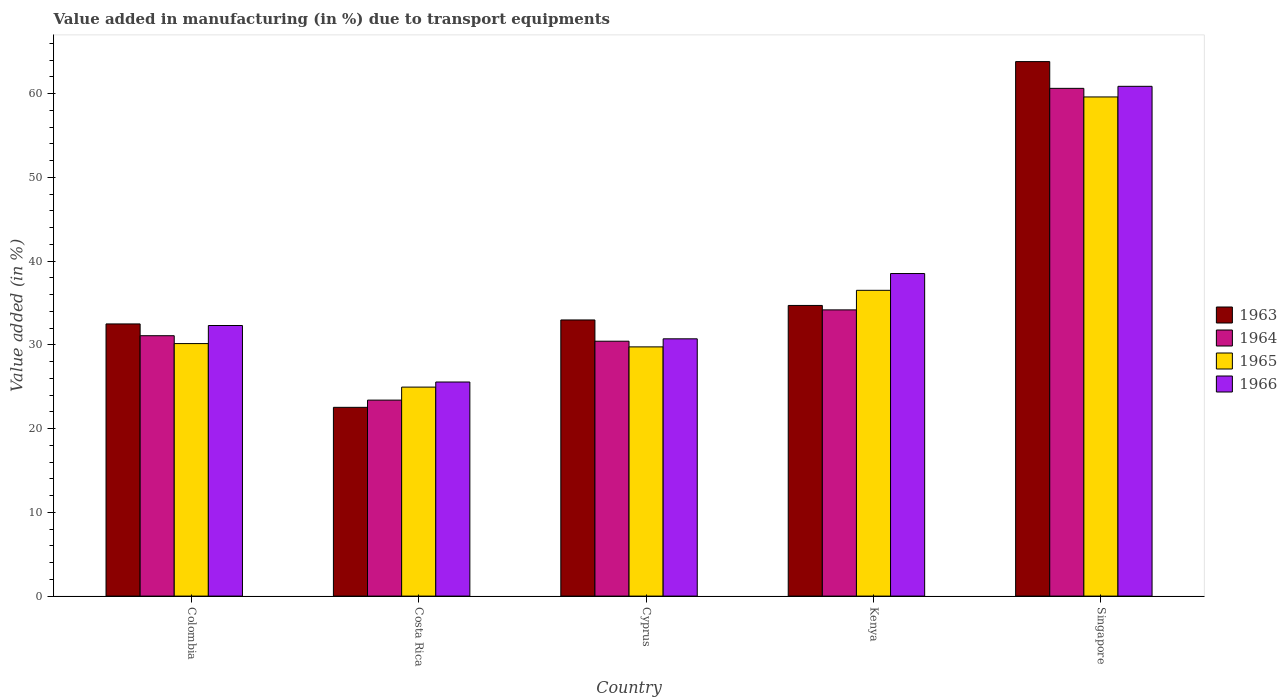How many different coloured bars are there?
Keep it short and to the point. 4. Are the number of bars on each tick of the X-axis equal?
Your answer should be compact. Yes. How many bars are there on the 4th tick from the left?
Provide a short and direct response. 4. How many bars are there on the 2nd tick from the right?
Keep it short and to the point. 4. What is the label of the 2nd group of bars from the left?
Make the answer very short. Costa Rica. What is the percentage of value added in manufacturing due to transport equipments in 1966 in Singapore?
Provide a short and direct response. 60.86. Across all countries, what is the maximum percentage of value added in manufacturing due to transport equipments in 1965?
Provide a succinct answer. 59.59. Across all countries, what is the minimum percentage of value added in manufacturing due to transport equipments in 1964?
Your answer should be very brief. 23.4. In which country was the percentage of value added in manufacturing due to transport equipments in 1965 maximum?
Ensure brevity in your answer.  Singapore. What is the total percentage of value added in manufacturing due to transport equipments in 1965 in the graph?
Provide a succinct answer. 180.94. What is the difference between the percentage of value added in manufacturing due to transport equipments in 1964 in Costa Rica and that in Singapore?
Make the answer very short. -37.22. What is the difference between the percentage of value added in manufacturing due to transport equipments in 1964 in Singapore and the percentage of value added in manufacturing due to transport equipments in 1966 in Kenya?
Ensure brevity in your answer.  22.11. What is the average percentage of value added in manufacturing due to transport equipments in 1965 per country?
Provide a succinct answer. 36.19. What is the difference between the percentage of value added in manufacturing due to transport equipments of/in 1963 and percentage of value added in manufacturing due to transport equipments of/in 1966 in Kenya?
Provide a short and direct response. -3.81. In how many countries, is the percentage of value added in manufacturing due to transport equipments in 1963 greater than 20 %?
Your answer should be compact. 5. What is the ratio of the percentage of value added in manufacturing due to transport equipments in 1966 in Colombia to that in Costa Rica?
Ensure brevity in your answer.  1.26. Is the difference between the percentage of value added in manufacturing due to transport equipments in 1963 in Colombia and Kenya greater than the difference between the percentage of value added in manufacturing due to transport equipments in 1966 in Colombia and Kenya?
Offer a very short reply. Yes. What is the difference between the highest and the second highest percentage of value added in manufacturing due to transport equipments in 1965?
Your response must be concise. 23.09. What is the difference between the highest and the lowest percentage of value added in manufacturing due to transport equipments in 1963?
Make the answer very short. 41.28. In how many countries, is the percentage of value added in manufacturing due to transport equipments in 1966 greater than the average percentage of value added in manufacturing due to transport equipments in 1966 taken over all countries?
Keep it short and to the point. 2. Is the sum of the percentage of value added in manufacturing due to transport equipments in 1966 in Costa Rica and Cyprus greater than the maximum percentage of value added in manufacturing due to transport equipments in 1964 across all countries?
Provide a succinct answer. No. What does the 2nd bar from the left in Colombia represents?
Provide a succinct answer. 1964. Are all the bars in the graph horizontal?
Your response must be concise. No. Are the values on the major ticks of Y-axis written in scientific E-notation?
Provide a succinct answer. No. What is the title of the graph?
Make the answer very short. Value added in manufacturing (in %) due to transport equipments. Does "1991" appear as one of the legend labels in the graph?
Give a very brief answer. No. What is the label or title of the Y-axis?
Provide a short and direct response. Value added (in %). What is the Value added (in %) of 1963 in Colombia?
Make the answer very short. 32.49. What is the Value added (in %) in 1964 in Colombia?
Offer a very short reply. 31.09. What is the Value added (in %) in 1965 in Colombia?
Your answer should be very brief. 30.15. What is the Value added (in %) in 1966 in Colombia?
Keep it short and to the point. 32.3. What is the Value added (in %) of 1963 in Costa Rica?
Your answer should be compact. 22.53. What is the Value added (in %) of 1964 in Costa Rica?
Give a very brief answer. 23.4. What is the Value added (in %) of 1965 in Costa Rica?
Ensure brevity in your answer.  24.95. What is the Value added (in %) of 1966 in Costa Rica?
Keep it short and to the point. 25.56. What is the Value added (in %) in 1963 in Cyprus?
Your answer should be compact. 32.97. What is the Value added (in %) of 1964 in Cyprus?
Offer a terse response. 30.43. What is the Value added (in %) in 1965 in Cyprus?
Your response must be concise. 29.75. What is the Value added (in %) in 1966 in Cyprus?
Provide a succinct answer. 30.72. What is the Value added (in %) in 1963 in Kenya?
Your answer should be very brief. 34.7. What is the Value added (in %) of 1964 in Kenya?
Your response must be concise. 34.17. What is the Value added (in %) of 1965 in Kenya?
Keep it short and to the point. 36.5. What is the Value added (in %) in 1966 in Kenya?
Make the answer very short. 38.51. What is the Value added (in %) of 1963 in Singapore?
Offer a very short reply. 63.81. What is the Value added (in %) of 1964 in Singapore?
Make the answer very short. 60.62. What is the Value added (in %) of 1965 in Singapore?
Ensure brevity in your answer.  59.59. What is the Value added (in %) of 1966 in Singapore?
Your answer should be compact. 60.86. Across all countries, what is the maximum Value added (in %) of 1963?
Give a very brief answer. 63.81. Across all countries, what is the maximum Value added (in %) in 1964?
Your answer should be compact. 60.62. Across all countries, what is the maximum Value added (in %) of 1965?
Ensure brevity in your answer.  59.59. Across all countries, what is the maximum Value added (in %) in 1966?
Your answer should be compact. 60.86. Across all countries, what is the minimum Value added (in %) in 1963?
Give a very brief answer. 22.53. Across all countries, what is the minimum Value added (in %) of 1964?
Provide a succinct answer. 23.4. Across all countries, what is the minimum Value added (in %) in 1965?
Keep it short and to the point. 24.95. Across all countries, what is the minimum Value added (in %) of 1966?
Offer a terse response. 25.56. What is the total Value added (in %) of 1963 in the graph?
Provide a short and direct response. 186.5. What is the total Value added (in %) of 1964 in the graph?
Provide a short and direct response. 179.7. What is the total Value added (in %) of 1965 in the graph?
Ensure brevity in your answer.  180.94. What is the total Value added (in %) of 1966 in the graph?
Your answer should be compact. 187.95. What is the difference between the Value added (in %) of 1963 in Colombia and that in Costa Rica?
Provide a succinct answer. 9.96. What is the difference between the Value added (in %) in 1964 in Colombia and that in Costa Rica?
Your answer should be very brief. 7.69. What is the difference between the Value added (in %) of 1965 in Colombia and that in Costa Rica?
Your answer should be compact. 5.2. What is the difference between the Value added (in %) in 1966 in Colombia and that in Costa Rica?
Provide a short and direct response. 6.74. What is the difference between the Value added (in %) in 1963 in Colombia and that in Cyprus?
Offer a very short reply. -0.47. What is the difference between the Value added (in %) of 1964 in Colombia and that in Cyprus?
Ensure brevity in your answer.  0.66. What is the difference between the Value added (in %) of 1965 in Colombia and that in Cyprus?
Your response must be concise. 0.39. What is the difference between the Value added (in %) in 1966 in Colombia and that in Cyprus?
Keep it short and to the point. 1.59. What is the difference between the Value added (in %) in 1963 in Colombia and that in Kenya?
Make the answer very short. -2.21. What is the difference between the Value added (in %) of 1964 in Colombia and that in Kenya?
Offer a terse response. -3.08. What is the difference between the Value added (in %) in 1965 in Colombia and that in Kenya?
Give a very brief answer. -6.36. What is the difference between the Value added (in %) of 1966 in Colombia and that in Kenya?
Make the answer very short. -6.2. What is the difference between the Value added (in %) in 1963 in Colombia and that in Singapore?
Offer a very short reply. -31.32. What is the difference between the Value added (in %) in 1964 in Colombia and that in Singapore?
Provide a short and direct response. -29.53. What is the difference between the Value added (in %) in 1965 in Colombia and that in Singapore?
Make the answer very short. -29.45. What is the difference between the Value added (in %) of 1966 in Colombia and that in Singapore?
Your answer should be compact. -28.56. What is the difference between the Value added (in %) of 1963 in Costa Rica and that in Cyprus?
Your answer should be very brief. -10.43. What is the difference between the Value added (in %) of 1964 in Costa Rica and that in Cyprus?
Make the answer very short. -7.03. What is the difference between the Value added (in %) in 1965 in Costa Rica and that in Cyprus?
Your answer should be compact. -4.8. What is the difference between the Value added (in %) of 1966 in Costa Rica and that in Cyprus?
Your answer should be very brief. -5.16. What is the difference between the Value added (in %) in 1963 in Costa Rica and that in Kenya?
Offer a very short reply. -12.17. What is the difference between the Value added (in %) of 1964 in Costa Rica and that in Kenya?
Your answer should be very brief. -10.77. What is the difference between the Value added (in %) in 1965 in Costa Rica and that in Kenya?
Make the answer very short. -11.55. What is the difference between the Value added (in %) of 1966 in Costa Rica and that in Kenya?
Give a very brief answer. -12.95. What is the difference between the Value added (in %) in 1963 in Costa Rica and that in Singapore?
Your answer should be very brief. -41.28. What is the difference between the Value added (in %) in 1964 in Costa Rica and that in Singapore?
Provide a short and direct response. -37.22. What is the difference between the Value added (in %) of 1965 in Costa Rica and that in Singapore?
Make the answer very short. -34.64. What is the difference between the Value added (in %) in 1966 in Costa Rica and that in Singapore?
Ensure brevity in your answer.  -35.3. What is the difference between the Value added (in %) of 1963 in Cyprus and that in Kenya?
Offer a terse response. -1.73. What is the difference between the Value added (in %) of 1964 in Cyprus and that in Kenya?
Give a very brief answer. -3.74. What is the difference between the Value added (in %) of 1965 in Cyprus and that in Kenya?
Ensure brevity in your answer.  -6.75. What is the difference between the Value added (in %) of 1966 in Cyprus and that in Kenya?
Your answer should be very brief. -7.79. What is the difference between the Value added (in %) in 1963 in Cyprus and that in Singapore?
Your answer should be compact. -30.84. What is the difference between the Value added (in %) of 1964 in Cyprus and that in Singapore?
Give a very brief answer. -30.19. What is the difference between the Value added (in %) in 1965 in Cyprus and that in Singapore?
Give a very brief answer. -29.84. What is the difference between the Value added (in %) in 1966 in Cyprus and that in Singapore?
Offer a terse response. -30.14. What is the difference between the Value added (in %) of 1963 in Kenya and that in Singapore?
Offer a terse response. -29.11. What is the difference between the Value added (in %) in 1964 in Kenya and that in Singapore?
Provide a succinct answer. -26.45. What is the difference between the Value added (in %) in 1965 in Kenya and that in Singapore?
Make the answer very short. -23.09. What is the difference between the Value added (in %) in 1966 in Kenya and that in Singapore?
Make the answer very short. -22.35. What is the difference between the Value added (in %) in 1963 in Colombia and the Value added (in %) in 1964 in Costa Rica?
Provide a succinct answer. 9.1. What is the difference between the Value added (in %) in 1963 in Colombia and the Value added (in %) in 1965 in Costa Rica?
Ensure brevity in your answer.  7.54. What is the difference between the Value added (in %) of 1963 in Colombia and the Value added (in %) of 1966 in Costa Rica?
Give a very brief answer. 6.93. What is the difference between the Value added (in %) of 1964 in Colombia and the Value added (in %) of 1965 in Costa Rica?
Your answer should be very brief. 6.14. What is the difference between the Value added (in %) of 1964 in Colombia and the Value added (in %) of 1966 in Costa Rica?
Your answer should be compact. 5.53. What is the difference between the Value added (in %) of 1965 in Colombia and the Value added (in %) of 1966 in Costa Rica?
Provide a short and direct response. 4.59. What is the difference between the Value added (in %) in 1963 in Colombia and the Value added (in %) in 1964 in Cyprus?
Your answer should be compact. 2.06. What is the difference between the Value added (in %) in 1963 in Colombia and the Value added (in %) in 1965 in Cyprus?
Make the answer very short. 2.74. What is the difference between the Value added (in %) of 1963 in Colombia and the Value added (in %) of 1966 in Cyprus?
Provide a succinct answer. 1.78. What is the difference between the Value added (in %) in 1964 in Colombia and the Value added (in %) in 1965 in Cyprus?
Make the answer very short. 1.33. What is the difference between the Value added (in %) in 1964 in Colombia and the Value added (in %) in 1966 in Cyprus?
Provide a short and direct response. 0.37. What is the difference between the Value added (in %) in 1965 in Colombia and the Value added (in %) in 1966 in Cyprus?
Keep it short and to the point. -0.57. What is the difference between the Value added (in %) in 1963 in Colombia and the Value added (in %) in 1964 in Kenya?
Your answer should be very brief. -1.68. What is the difference between the Value added (in %) of 1963 in Colombia and the Value added (in %) of 1965 in Kenya?
Ensure brevity in your answer.  -4.01. What is the difference between the Value added (in %) in 1963 in Colombia and the Value added (in %) in 1966 in Kenya?
Keep it short and to the point. -6.01. What is the difference between the Value added (in %) in 1964 in Colombia and the Value added (in %) in 1965 in Kenya?
Your response must be concise. -5.42. What is the difference between the Value added (in %) of 1964 in Colombia and the Value added (in %) of 1966 in Kenya?
Your answer should be compact. -7.42. What is the difference between the Value added (in %) in 1965 in Colombia and the Value added (in %) in 1966 in Kenya?
Offer a terse response. -8.36. What is the difference between the Value added (in %) in 1963 in Colombia and the Value added (in %) in 1964 in Singapore?
Ensure brevity in your answer.  -28.12. What is the difference between the Value added (in %) of 1963 in Colombia and the Value added (in %) of 1965 in Singapore?
Keep it short and to the point. -27.1. What is the difference between the Value added (in %) in 1963 in Colombia and the Value added (in %) in 1966 in Singapore?
Your answer should be very brief. -28.37. What is the difference between the Value added (in %) in 1964 in Colombia and the Value added (in %) in 1965 in Singapore?
Provide a short and direct response. -28.51. What is the difference between the Value added (in %) of 1964 in Colombia and the Value added (in %) of 1966 in Singapore?
Keep it short and to the point. -29.77. What is the difference between the Value added (in %) of 1965 in Colombia and the Value added (in %) of 1966 in Singapore?
Ensure brevity in your answer.  -30.71. What is the difference between the Value added (in %) in 1963 in Costa Rica and the Value added (in %) in 1964 in Cyprus?
Your response must be concise. -7.9. What is the difference between the Value added (in %) of 1963 in Costa Rica and the Value added (in %) of 1965 in Cyprus?
Offer a very short reply. -7.22. What is the difference between the Value added (in %) in 1963 in Costa Rica and the Value added (in %) in 1966 in Cyprus?
Ensure brevity in your answer.  -8.18. What is the difference between the Value added (in %) of 1964 in Costa Rica and the Value added (in %) of 1965 in Cyprus?
Offer a very short reply. -6.36. What is the difference between the Value added (in %) of 1964 in Costa Rica and the Value added (in %) of 1966 in Cyprus?
Your response must be concise. -7.32. What is the difference between the Value added (in %) in 1965 in Costa Rica and the Value added (in %) in 1966 in Cyprus?
Ensure brevity in your answer.  -5.77. What is the difference between the Value added (in %) of 1963 in Costa Rica and the Value added (in %) of 1964 in Kenya?
Make the answer very short. -11.64. What is the difference between the Value added (in %) in 1963 in Costa Rica and the Value added (in %) in 1965 in Kenya?
Provide a succinct answer. -13.97. What is the difference between the Value added (in %) of 1963 in Costa Rica and the Value added (in %) of 1966 in Kenya?
Keep it short and to the point. -15.97. What is the difference between the Value added (in %) of 1964 in Costa Rica and the Value added (in %) of 1965 in Kenya?
Your answer should be compact. -13.11. What is the difference between the Value added (in %) in 1964 in Costa Rica and the Value added (in %) in 1966 in Kenya?
Your response must be concise. -15.11. What is the difference between the Value added (in %) of 1965 in Costa Rica and the Value added (in %) of 1966 in Kenya?
Give a very brief answer. -13.56. What is the difference between the Value added (in %) in 1963 in Costa Rica and the Value added (in %) in 1964 in Singapore?
Your response must be concise. -38.08. What is the difference between the Value added (in %) in 1963 in Costa Rica and the Value added (in %) in 1965 in Singapore?
Give a very brief answer. -37.06. What is the difference between the Value added (in %) in 1963 in Costa Rica and the Value added (in %) in 1966 in Singapore?
Offer a terse response. -38.33. What is the difference between the Value added (in %) of 1964 in Costa Rica and the Value added (in %) of 1965 in Singapore?
Your answer should be compact. -36.19. What is the difference between the Value added (in %) in 1964 in Costa Rica and the Value added (in %) in 1966 in Singapore?
Keep it short and to the point. -37.46. What is the difference between the Value added (in %) of 1965 in Costa Rica and the Value added (in %) of 1966 in Singapore?
Give a very brief answer. -35.91. What is the difference between the Value added (in %) of 1963 in Cyprus and the Value added (in %) of 1964 in Kenya?
Provide a succinct answer. -1.2. What is the difference between the Value added (in %) of 1963 in Cyprus and the Value added (in %) of 1965 in Kenya?
Your response must be concise. -3.54. What is the difference between the Value added (in %) of 1963 in Cyprus and the Value added (in %) of 1966 in Kenya?
Give a very brief answer. -5.54. What is the difference between the Value added (in %) in 1964 in Cyprus and the Value added (in %) in 1965 in Kenya?
Offer a very short reply. -6.07. What is the difference between the Value added (in %) in 1964 in Cyprus and the Value added (in %) in 1966 in Kenya?
Offer a terse response. -8.08. What is the difference between the Value added (in %) of 1965 in Cyprus and the Value added (in %) of 1966 in Kenya?
Make the answer very short. -8.75. What is the difference between the Value added (in %) of 1963 in Cyprus and the Value added (in %) of 1964 in Singapore?
Ensure brevity in your answer.  -27.65. What is the difference between the Value added (in %) of 1963 in Cyprus and the Value added (in %) of 1965 in Singapore?
Your response must be concise. -26.62. What is the difference between the Value added (in %) in 1963 in Cyprus and the Value added (in %) in 1966 in Singapore?
Keep it short and to the point. -27.89. What is the difference between the Value added (in %) of 1964 in Cyprus and the Value added (in %) of 1965 in Singapore?
Provide a succinct answer. -29.16. What is the difference between the Value added (in %) of 1964 in Cyprus and the Value added (in %) of 1966 in Singapore?
Keep it short and to the point. -30.43. What is the difference between the Value added (in %) in 1965 in Cyprus and the Value added (in %) in 1966 in Singapore?
Your response must be concise. -31.11. What is the difference between the Value added (in %) in 1963 in Kenya and the Value added (in %) in 1964 in Singapore?
Ensure brevity in your answer.  -25.92. What is the difference between the Value added (in %) of 1963 in Kenya and the Value added (in %) of 1965 in Singapore?
Provide a short and direct response. -24.89. What is the difference between the Value added (in %) of 1963 in Kenya and the Value added (in %) of 1966 in Singapore?
Your answer should be compact. -26.16. What is the difference between the Value added (in %) in 1964 in Kenya and the Value added (in %) in 1965 in Singapore?
Make the answer very short. -25.42. What is the difference between the Value added (in %) in 1964 in Kenya and the Value added (in %) in 1966 in Singapore?
Provide a short and direct response. -26.69. What is the difference between the Value added (in %) of 1965 in Kenya and the Value added (in %) of 1966 in Singapore?
Offer a very short reply. -24.36. What is the average Value added (in %) of 1963 per country?
Ensure brevity in your answer.  37.3. What is the average Value added (in %) in 1964 per country?
Your answer should be compact. 35.94. What is the average Value added (in %) of 1965 per country?
Provide a short and direct response. 36.19. What is the average Value added (in %) in 1966 per country?
Provide a short and direct response. 37.59. What is the difference between the Value added (in %) in 1963 and Value added (in %) in 1964 in Colombia?
Give a very brief answer. 1.41. What is the difference between the Value added (in %) of 1963 and Value added (in %) of 1965 in Colombia?
Offer a terse response. 2.35. What is the difference between the Value added (in %) of 1963 and Value added (in %) of 1966 in Colombia?
Give a very brief answer. 0.19. What is the difference between the Value added (in %) of 1964 and Value added (in %) of 1965 in Colombia?
Give a very brief answer. 0.94. What is the difference between the Value added (in %) in 1964 and Value added (in %) in 1966 in Colombia?
Make the answer very short. -1.22. What is the difference between the Value added (in %) of 1965 and Value added (in %) of 1966 in Colombia?
Make the answer very short. -2.16. What is the difference between the Value added (in %) in 1963 and Value added (in %) in 1964 in Costa Rica?
Provide a succinct answer. -0.86. What is the difference between the Value added (in %) in 1963 and Value added (in %) in 1965 in Costa Rica?
Keep it short and to the point. -2.42. What is the difference between the Value added (in %) in 1963 and Value added (in %) in 1966 in Costa Rica?
Ensure brevity in your answer.  -3.03. What is the difference between the Value added (in %) of 1964 and Value added (in %) of 1965 in Costa Rica?
Your answer should be very brief. -1.55. What is the difference between the Value added (in %) in 1964 and Value added (in %) in 1966 in Costa Rica?
Offer a terse response. -2.16. What is the difference between the Value added (in %) in 1965 and Value added (in %) in 1966 in Costa Rica?
Provide a short and direct response. -0.61. What is the difference between the Value added (in %) of 1963 and Value added (in %) of 1964 in Cyprus?
Make the answer very short. 2.54. What is the difference between the Value added (in %) of 1963 and Value added (in %) of 1965 in Cyprus?
Your answer should be very brief. 3.21. What is the difference between the Value added (in %) in 1963 and Value added (in %) in 1966 in Cyprus?
Make the answer very short. 2.25. What is the difference between the Value added (in %) in 1964 and Value added (in %) in 1965 in Cyprus?
Offer a very short reply. 0.68. What is the difference between the Value added (in %) in 1964 and Value added (in %) in 1966 in Cyprus?
Provide a succinct answer. -0.29. What is the difference between the Value added (in %) in 1965 and Value added (in %) in 1966 in Cyprus?
Offer a very short reply. -0.96. What is the difference between the Value added (in %) of 1963 and Value added (in %) of 1964 in Kenya?
Your answer should be compact. 0.53. What is the difference between the Value added (in %) of 1963 and Value added (in %) of 1965 in Kenya?
Keep it short and to the point. -1.8. What is the difference between the Value added (in %) in 1963 and Value added (in %) in 1966 in Kenya?
Ensure brevity in your answer.  -3.81. What is the difference between the Value added (in %) in 1964 and Value added (in %) in 1965 in Kenya?
Make the answer very short. -2.33. What is the difference between the Value added (in %) of 1964 and Value added (in %) of 1966 in Kenya?
Give a very brief answer. -4.34. What is the difference between the Value added (in %) of 1965 and Value added (in %) of 1966 in Kenya?
Make the answer very short. -2. What is the difference between the Value added (in %) of 1963 and Value added (in %) of 1964 in Singapore?
Provide a short and direct response. 3.19. What is the difference between the Value added (in %) in 1963 and Value added (in %) in 1965 in Singapore?
Ensure brevity in your answer.  4.22. What is the difference between the Value added (in %) of 1963 and Value added (in %) of 1966 in Singapore?
Provide a short and direct response. 2.95. What is the difference between the Value added (in %) in 1964 and Value added (in %) in 1965 in Singapore?
Your answer should be very brief. 1.03. What is the difference between the Value added (in %) of 1964 and Value added (in %) of 1966 in Singapore?
Offer a terse response. -0.24. What is the difference between the Value added (in %) of 1965 and Value added (in %) of 1966 in Singapore?
Ensure brevity in your answer.  -1.27. What is the ratio of the Value added (in %) in 1963 in Colombia to that in Costa Rica?
Provide a succinct answer. 1.44. What is the ratio of the Value added (in %) of 1964 in Colombia to that in Costa Rica?
Your answer should be very brief. 1.33. What is the ratio of the Value added (in %) of 1965 in Colombia to that in Costa Rica?
Ensure brevity in your answer.  1.21. What is the ratio of the Value added (in %) of 1966 in Colombia to that in Costa Rica?
Provide a succinct answer. 1.26. What is the ratio of the Value added (in %) in 1963 in Colombia to that in Cyprus?
Your response must be concise. 0.99. What is the ratio of the Value added (in %) in 1964 in Colombia to that in Cyprus?
Keep it short and to the point. 1.02. What is the ratio of the Value added (in %) of 1965 in Colombia to that in Cyprus?
Your answer should be very brief. 1.01. What is the ratio of the Value added (in %) in 1966 in Colombia to that in Cyprus?
Make the answer very short. 1.05. What is the ratio of the Value added (in %) of 1963 in Colombia to that in Kenya?
Provide a short and direct response. 0.94. What is the ratio of the Value added (in %) in 1964 in Colombia to that in Kenya?
Your answer should be compact. 0.91. What is the ratio of the Value added (in %) of 1965 in Colombia to that in Kenya?
Keep it short and to the point. 0.83. What is the ratio of the Value added (in %) in 1966 in Colombia to that in Kenya?
Your answer should be very brief. 0.84. What is the ratio of the Value added (in %) of 1963 in Colombia to that in Singapore?
Offer a terse response. 0.51. What is the ratio of the Value added (in %) in 1964 in Colombia to that in Singapore?
Provide a succinct answer. 0.51. What is the ratio of the Value added (in %) in 1965 in Colombia to that in Singapore?
Make the answer very short. 0.51. What is the ratio of the Value added (in %) in 1966 in Colombia to that in Singapore?
Offer a terse response. 0.53. What is the ratio of the Value added (in %) in 1963 in Costa Rica to that in Cyprus?
Provide a short and direct response. 0.68. What is the ratio of the Value added (in %) of 1964 in Costa Rica to that in Cyprus?
Keep it short and to the point. 0.77. What is the ratio of the Value added (in %) of 1965 in Costa Rica to that in Cyprus?
Give a very brief answer. 0.84. What is the ratio of the Value added (in %) of 1966 in Costa Rica to that in Cyprus?
Your answer should be very brief. 0.83. What is the ratio of the Value added (in %) of 1963 in Costa Rica to that in Kenya?
Provide a succinct answer. 0.65. What is the ratio of the Value added (in %) of 1964 in Costa Rica to that in Kenya?
Your response must be concise. 0.68. What is the ratio of the Value added (in %) in 1965 in Costa Rica to that in Kenya?
Keep it short and to the point. 0.68. What is the ratio of the Value added (in %) in 1966 in Costa Rica to that in Kenya?
Provide a short and direct response. 0.66. What is the ratio of the Value added (in %) of 1963 in Costa Rica to that in Singapore?
Your response must be concise. 0.35. What is the ratio of the Value added (in %) in 1964 in Costa Rica to that in Singapore?
Your answer should be very brief. 0.39. What is the ratio of the Value added (in %) in 1965 in Costa Rica to that in Singapore?
Give a very brief answer. 0.42. What is the ratio of the Value added (in %) of 1966 in Costa Rica to that in Singapore?
Provide a succinct answer. 0.42. What is the ratio of the Value added (in %) of 1963 in Cyprus to that in Kenya?
Provide a succinct answer. 0.95. What is the ratio of the Value added (in %) of 1964 in Cyprus to that in Kenya?
Your response must be concise. 0.89. What is the ratio of the Value added (in %) in 1965 in Cyprus to that in Kenya?
Provide a succinct answer. 0.82. What is the ratio of the Value added (in %) in 1966 in Cyprus to that in Kenya?
Give a very brief answer. 0.8. What is the ratio of the Value added (in %) of 1963 in Cyprus to that in Singapore?
Give a very brief answer. 0.52. What is the ratio of the Value added (in %) in 1964 in Cyprus to that in Singapore?
Provide a short and direct response. 0.5. What is the ratio of the Value added (in %) in 1965 in Cyprus to that in Singapore?
Your answer should be compact. 0.5. What is the ratio of the Value added (in %) in 1966 in Cyprus to that in Singapore?
Provide a short and direct response. 0.5. What is the ratio of the Value added (in %) in 1963 in Kenya to that in Singapore?
Keep it short and to the point. 0.54. What is the ratio of the Value added (in %) of 1964 in Kenya to that in Singapore?
Give a very brief answer. 0.56. What is the ratio of the Value added (in %) of 1965 in Kenya to that in Singapore?
Make the answer very short. 0.61. What is the ratio of the Value added (in %) of 1966 in Kenya to that in Singapore?
Keep it short and to the point. 0.63. What is the difference between the highest and the second highest Value added (in %) in 1963?
Offer a very short reply. 29.11. What is the difference between the highest and the second highest Value added (in %) in 1964?
Offer a terse response. 26.45. What is the difference between the highest and the second highest Value added (in %) of 1965?
Keep it short and to the point. 23.09. What is the difference between the highest and the second highest Value added (in %) of 1966?
Provide a succinct answer. 22.35. What is the difference between the highest and the lowest Value added (in %) of 1963?
Give a very brief answer. 41.28. What is the difference between the highest and the lowest Value added (in %) in 1964?
Ensure brevity in your answer.  37.22. What is the difference between the highest and the lowest Value added (in %) of 1965?
Ensure brevity in your answer.  34.64. What is the difference between the highest and the lowest Value added (in %) of 1966?
Keep it short and to the point. 35.3. 